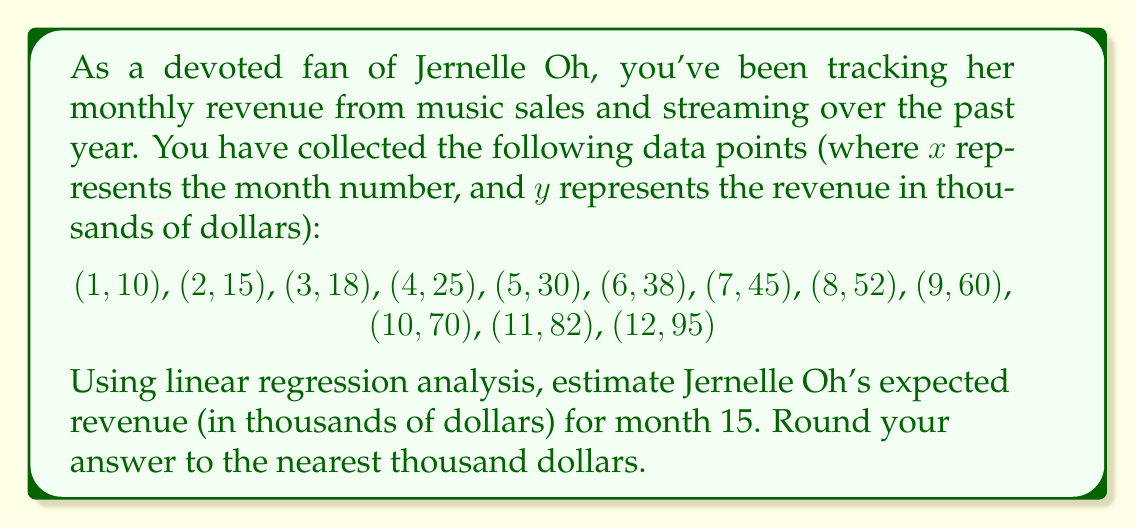Can you answer this question? To solve this problem, we'll use linear regression to find the line of best fit for the given data points, and then use that line to predict the revenue for month 15.

1. First, let's calculate the necessary sums:
   $n = 12$ (number of data points)
   $\sum x = 78$
   $\sum y = 540$
   $\sum xy = 4,291$
   $\sum x^2 = 650$

2. Now, we can use the linear regression formulas to find the slope (m) and y-intercept (b):

   $m = \frac{n\sum xy - \sum x \sum y}{n\sum x^2 - (\sum x)^2}$

   $m = \frac{12(4,291) - 78(540)}{12(650) - 78^2} = \frac{51,492 - 42,120}{7,800 - 6,084} = \frac{9,372}{1,716} \approx 5.46$

   $b = \frac{\sum y - m\sum x}{n}$

   $b = \frac{540 - 5.46(78)}{12} = \frac{540 - 425.88}{12} \approx 9.51$

3. The equation of the line of best fit is:
   $y = 5.46x + 9.51$

4. To estimate the revenue for month 15, we substitute x = 15 into our equation:
   $y = 5.46(15) + 9.51 = 81.9 + 9.51 = 91.41$

5. Rounding to the nearest thousand dollars:
   91.41 thousand dollars ≈ 91 thousand dollars
Answer: $91,000 